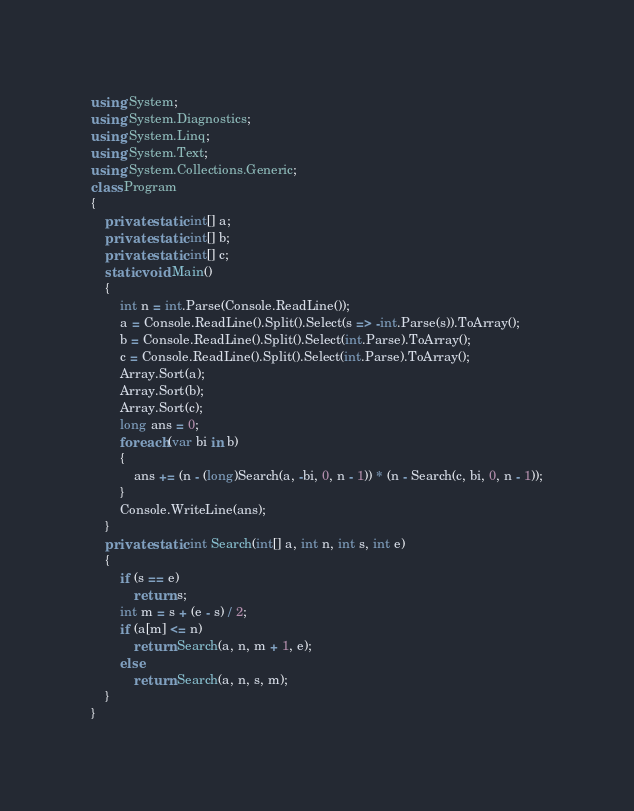Convert code to text. <code><loc_0><loc_0><loc_500><loc_500><_C#_>using System;
using System.Diagnostics;
using System.Linq;
using System.Text;
using System.Collections.Generic;
class Program
{
    private static int[] a;
    private static int[] b;
    private static int[] c;
    static void Main()
    {
        int n = int.Parse(Console.ReadLine());
        a = Console.ReadLine().Split().Select(s => -int.Parse(s)).ToArray();
        b = Console.ReadLine().Split().Select(int.Parse).ToArray();
        c = Console.ReadLine().Split().Select(int.Parse).ToArray();
        Array.Sort(a);
        Array.Sort(b);
        Array.Sort(c);
        long ans = 0;
        foreach (var bi in b)
        {
            ans += (n - (long)Search(a, -bi, 0, n - 1)) * (n - Search(c, bi, 0, n - 1));
        }
        Console.WriteLine(ans);
    }
    private static int Search(int[] a, int n, int s, int e)
    {
        if (s == e)
            return s;
        int m = s + (e - s) / 2;
        if (a[m] <= n)
            return Search(a, n, m + 1, e);
        else
            return Search(a, n, s, m);
    }
}</code> 